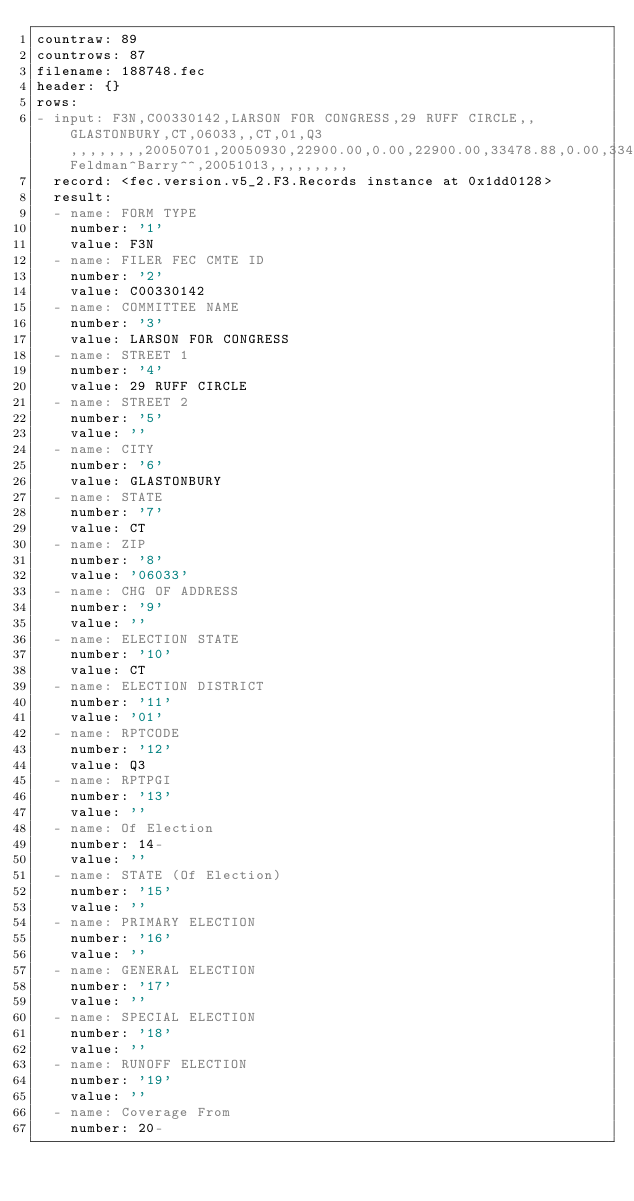<code> <loc_0><loc_0><loc_500><loc_500><_YAML_>countraw: 89
countrows: 87
filename: 188748.fec
header: {}
rows:
- input: F3N,C00330142,LARSON FOR CONGRESS,29 RUFF CIRCLE,,GLASTONBURY,CT,06033,,CT,01,Q3,,,,,,,,20050701,20050930,22900.00,0.00,22900.00,33478.88,0.00,33478.88,206228.37,0.00,530.00,2750.00,1150.00,3900.00,0.00,19000.00,0.00,22900.00,0.00,0.00,0.00,0.00,0.00,1112.24,24012.24,33478.88,0.00,0.00,0.00,0.00,0.00,0.00,0.00,0.00,10000.00,43478.88,225695.01,24012.24,249707.25,43478.88,206228.37,195222.30,5500.00,189722.30,126631.13,331.44,126299.69,82957.30,8765.00,91722.30,0.00,103500.00,0.00,195222.30,0.00,0.00,0.00,0.00,331.44,2824.75,198378.49,126631.13,0.00,0.00,0.00,0.00,0.00,5500.00,0.00,5500.00,90100.00,222231.13,Feldman^Barry^^,20051013,,,,,,,,,
  record: <fec.version.v5_2.F3.Records instance at 0x1dd0128>
  result:
  - name: FORM TYPE
    number: '1'
    value: F3N
  - name: FILER FEC CMTE ID
    number: '2'
    value: C00330142
  - name: COMMITTEE NAME
    number: '3'
    value: LARSON FOR CONGRESS
  - name: STREET 1
    number: '4'
    value: 29 RUFF CIRCLE
  - name: STREET 2
    number: '5'
    value: ''
  - name: CITY
    number: '6'
    value: GLASTONBURY
  - name: STATE
    number: '7'
    value: CT
  - name: ZIP
    number: '8'
    value: '06033'
  - name: CHG OF ADDRESS
    number: '9'
    value: ''
  - name: ELECTION STATE
    number: '10'
    value: CT
  - name: ELECTION DISTRICT
    number: '11'
    value: '01'
  - name: RPTCODE
    number: '12'
    value: Q3
  - name: RPTPGI
    number: '13'
    value: ''
  - name: Of Election
    number: 14-
    value: ''
  - name: STATE (Of Election)
    number: '15'
    value: ''
  - name: PRIMARY ELECTION
    number: '16'
    value: ''
  - name: GENERAL ELECTION
    number: '17'
    value: ''
  - name: SPECIAL ELECTION
    number: '18'
    value: ''
  - name: RUNOFF ELECTION
    number: '19'
    value: ''
  - name: Coverage From
    number: 20-</code> 